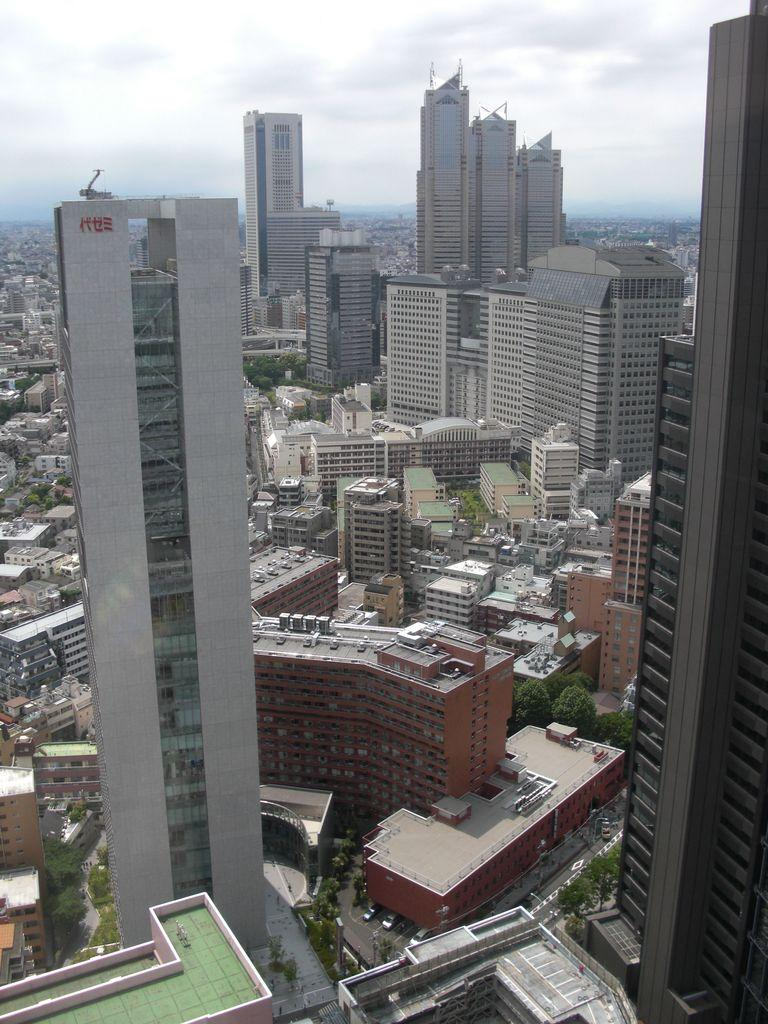What type of structures are visible in the image? There are buildings with windows in the image. What natural elements can be seen in the image? There is a group of trees in the image. What are the tall, thin objects in the image? There are poles in the image. What is visible at the top of the image? The sky is visible at the top of the image. Can you see the partner holding a gun in the image? There is no partner or gun present in the image. How many wings are visible on the buildings in the image? There are no wings visible on the buildings in the image; they are typical structures with windows and walls. 